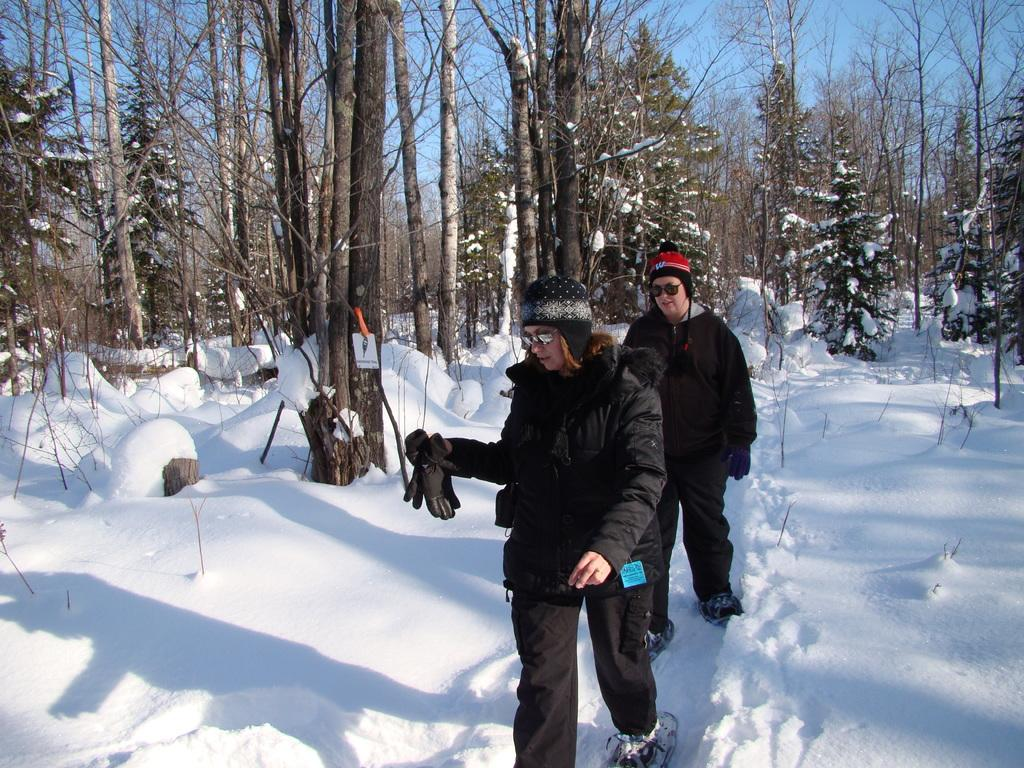How many people are in the image? There are two people in the image. What are the people doing in the image? The people are walking on the snow. What protective gear are the people wearing? The people are wearing goggles and caps. What can be seen in the background of the image? There are trees, a board, and the sky visible in the background of the image. What type of coat is the giraffe wearing in the image? There is no giraffe present in the image, and therefore no coat can be observed. 